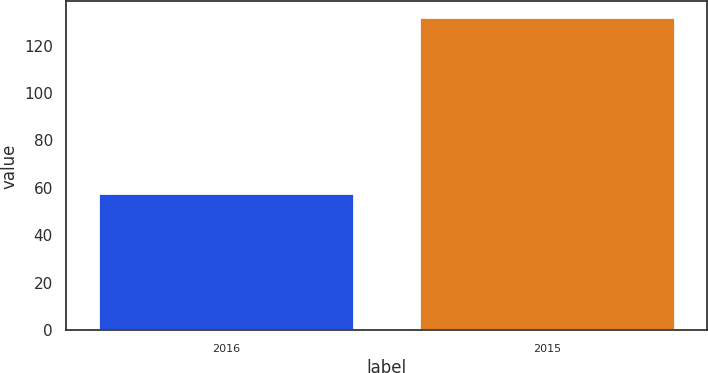Convert chart. <chart><loc_0><loc_0><loc_500><loc_500><bar_chart><fcel>2016<fcel>2015<nl><fcel>58<fcel>132<nl></chart> 